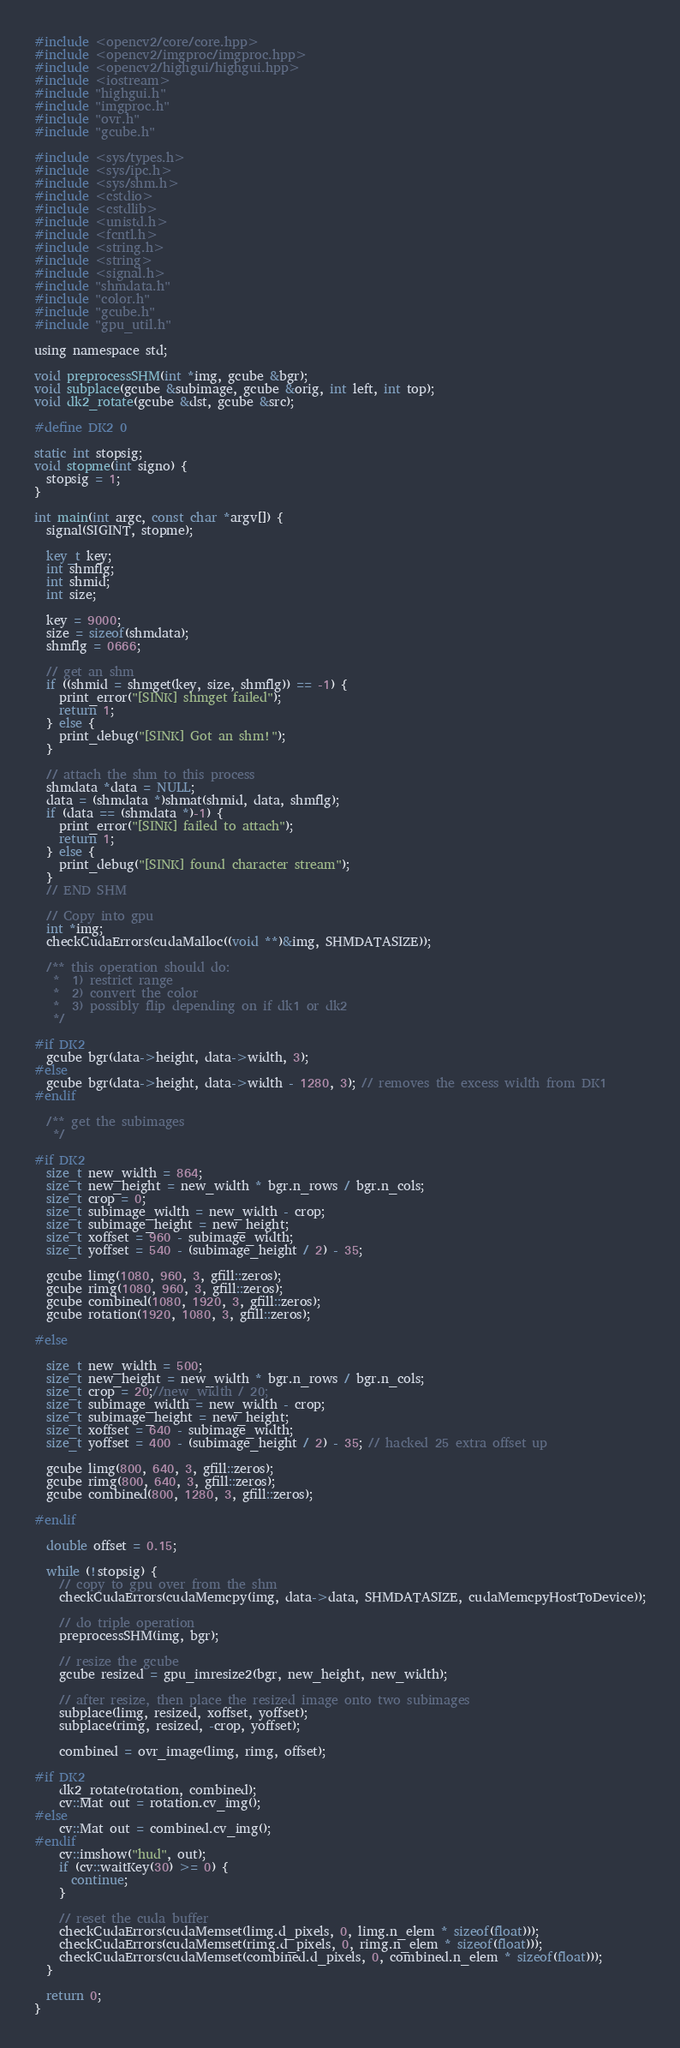Convert code to text. <code><loc_0><loc_0><loc_500><loc_500><_Cuda_>#include <opencv2/core/core.hpp>
#include <opencv2/imgproc/imgproc.hpp>
#include <opencv2/highgui/highgui.hpp>
#include <iostream>
#include "highgui.h"
#include "imgproc.h"
#include "ovr.h"
#include "gcube.h"

#include <sys/types.h>
#include <sys/ipc.h>
#include <sys/shm.h>
#include <cstdio>
#include <cstdlib>
#include <unistd.h>
#include <fcntl.h>
#include <string.h>
#include <string>
#include <signal.h>
#include "shmdata.h"
#include "color.h"
#include "gcube.h"
#include "gpu_util.h"

using namespace std;

void preprocessSHM(int *img, gcube &bgr);
void subplace(gcube &subimage, gcube &orig, int left, int top);
void dk2_rotate(gcube &dst, gcube &src);

#define DK2 0

static int stopsig;
void stopme(int signo) {
  stopsig = 1;
}

int main(int argc, const char *argv[]) {
  signal(SIGINT, stopme);

  key_t key;
  int shmflg;
  int shmid;
  int size;

  key = 9000;
  size = sizeof(shmdata);
  shmflg = 0666;

  // get an shm
  if ((shmid = shmget(key, size, shmflg)) == -1) {
    print_error("[SINK] shmget failed");
    return 1;
  } else {
    print_debug("[SINK] Got an shm!");
  }

  // attach the shm to this process
  shmdata *data = NULL;
  data = (shmdata *)shmat(shmid, data, shmflg);
  if (data == (shmdata *)-1) {
    print_error("[SINK] failed to attach");
    return 1;
  } else {
    print_debug("[SINK] found character stream");
  }
  // END SHM

  // Copy into gpu
  int *img;
  checkCudaErrors(cudaMalloc((void **)&img, SHMDATASIZE));

  /** this operation should do:
   *  1) restrict range
   *  2) convert the color
   *  3) possibly flip depending on if dk1 or dk2
   */

#if DK2
  gcube bgr(data->height, data->width, 3);
#else
  gcube bgr(data->height, data->width - 1280, 3); // removes the excess width from DK1
#endif

  /** get the subimages
   */

#if DK2
  size_t new_width = 864;
  size_t new_height = new_width * bgr.n_rows / bgr.n_cols;
  size_t crop = 0;
  size_t subimage_width = new_width - crop;
  size_t subimage_height = new_height;
  size_t xoffset = 960 - subimage_width;
  size_t yoffset = 540 - (subimage_height / 2) - 35;

  gcube limg(1080, 960, 3, gfill::zeros);
  gcube rimg(1080, 960, 3, gfill::zeros);
  gcube combined(1080, 1920, 3, gfill::zeros);
  gcube rotation(1920, 1080, 3, gfill::zeros);

#else

  size_t new_width = 500;
  size_t new_height = new_width * bgr.n_rows / bgr.n_cols;
  size_t crop = 20;//new_width / 20;
  size_t subimage_width = new_width - crop;
  size_t subimage_height = new_height;
  size_t xoffset = 640 - subimage_width;
  size_t yoffset = 400 - (subimage_height / 2) - 35; // hacked 25 extra offset up

  gcube limg(800, 640, 3, gfill::zeros);
  gcube rimg(800, 640, 3, gfill::zeros);
  gcube combined(800, 1280, 3, gfill::zeros);

#endif

  double offset = 0.15;

  while (!stopsig) {
    // copy to gpu over from the shm
    checkCudaErrors(cudaMemcpy(img, data->data, SHMDATASIZE, cudaMemcpyHostToDevice));

    // do triple operation
    preprocessSHM(img, bgr);

    // resize the gcube
    gcube resized = gpu_imresize2(bgr, new_height, new_width);

    // after resize, then place the resized image onto two subimages
    subplace(limg, resized, xoffset, yoffset);
    subplace(rimg, resized, -crop, yoffset);

    combined = ovr_image(limg, rimg, offset);

#if DK2
    dk2_rotate(rotation, combined);
    cv::Mat out = rotation.cv_img();
#else
    cv::Mat out = combined.cv_img();
#endif
    cv::imshow("hud", out);
    if (cv::waitKey(30) >= 0) {
      continue;
    }

    // reset the cuda buffer
    checkCudaErrors(cudaMemset(limg.d_pixels, 0, limg.n_elem * sizeof(float)));
    checkCudaErrors(cudaMemset(rimg.d_pixels, 0, rimg.n_elem * sizeof(float)));
    checkCudaErrors(cudaMemset(combined.d_pixels, 0, combined.n_elem * sizeof(float)));
  }

  return 0;
}
</code> 